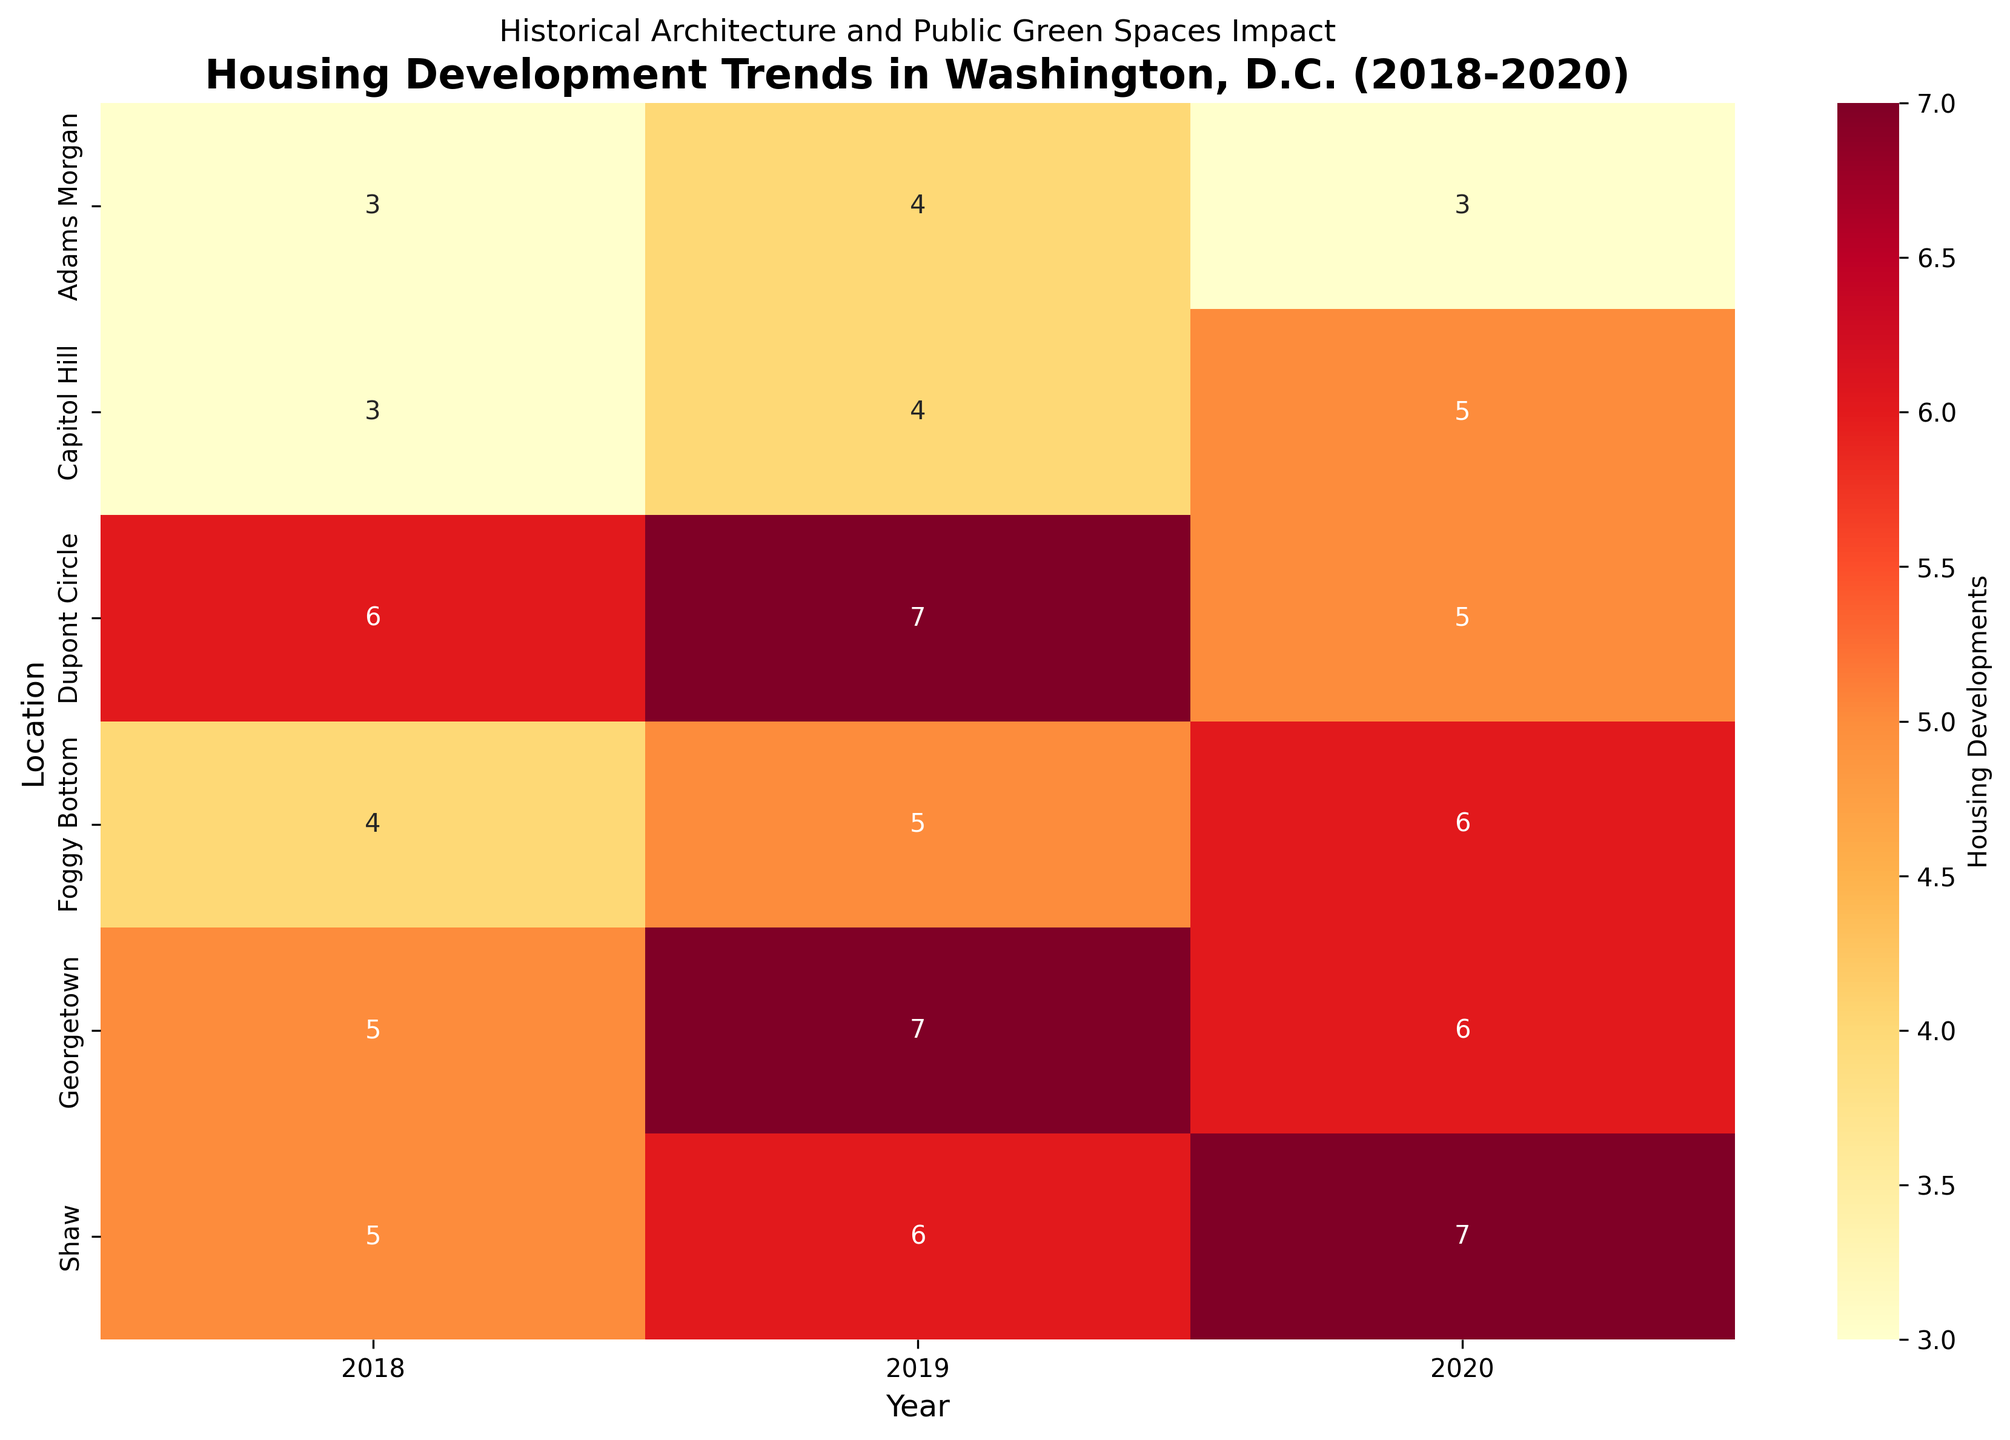What's the title of the heatmap? The title of the heatmap is usually located at the top of the figure. In this case, it reads "Housing Development Trends in Washington, D.C. (2018-2020)".
Answer: Housing Development Trends in Washington, D.C. (2018-2020) What year did Shaw have the highest number of housing developments? Locate Shaw on the y-axis and scan across the x-axis to find the year with the highest value. It is clear that in 2020, Shaw had the highest number of housing developments with 7.
Answer: 2020 Which location had the least housing developments in 2018? Scan down the 2018 column to find the smallest number. It shows that Capitol Hill and Adams Morgan both had the least housing developments, with a value of 3 each.
Answer: Capitol Hill and Adams Morgan Which location showed an increase in housing developments every year? Compare the values for each location across the years 2018 to 2020. Foggy Bottom showed an increase each year (4 in 2018, 5 in 2019, and 6 in 2020).
Answer: Foggy Bottom What is the average number of housing developments in Dupont Circle from 2018 to 2020? Add the yearly values for Dupont Circle (6 in 2018, 7 in 2019, 5 in 2020), then divide by the number of years (3). (6 + 7 + 5) / 3 = 18 / 3 = 6
Answer: 6 Which location had the highest housing developments in 2019? Scan down the 2019 column to find the largest number. The highest number of housing developments in 2019 is 7, located in both Georgetown and Dupont Circle.
Answer: Georgetown and Dupont Circle How many total housing developments were there in Capitol Hill from 2018 to 2020? Add the yearly values for Capitol Hill (3 in 2018, 4 in 2019, 5 in 2020). 3 + 4 + 5 = 12
Answer: 12 Which location had the most consistent number of housing developments over the years? Look for a location where the values are close to each other for all three years. Adams Morgan has values of 3, 4, and 3, which is the most consistent pattern.
Answer: Adams Morgan In which year did Georgetown see a reduction in housing developments compared to the previous year? Compare the values year by year for Georgetown. Georgetown had 7 in 2019, then reduced to 6 in 2020.
Answer: 2020 